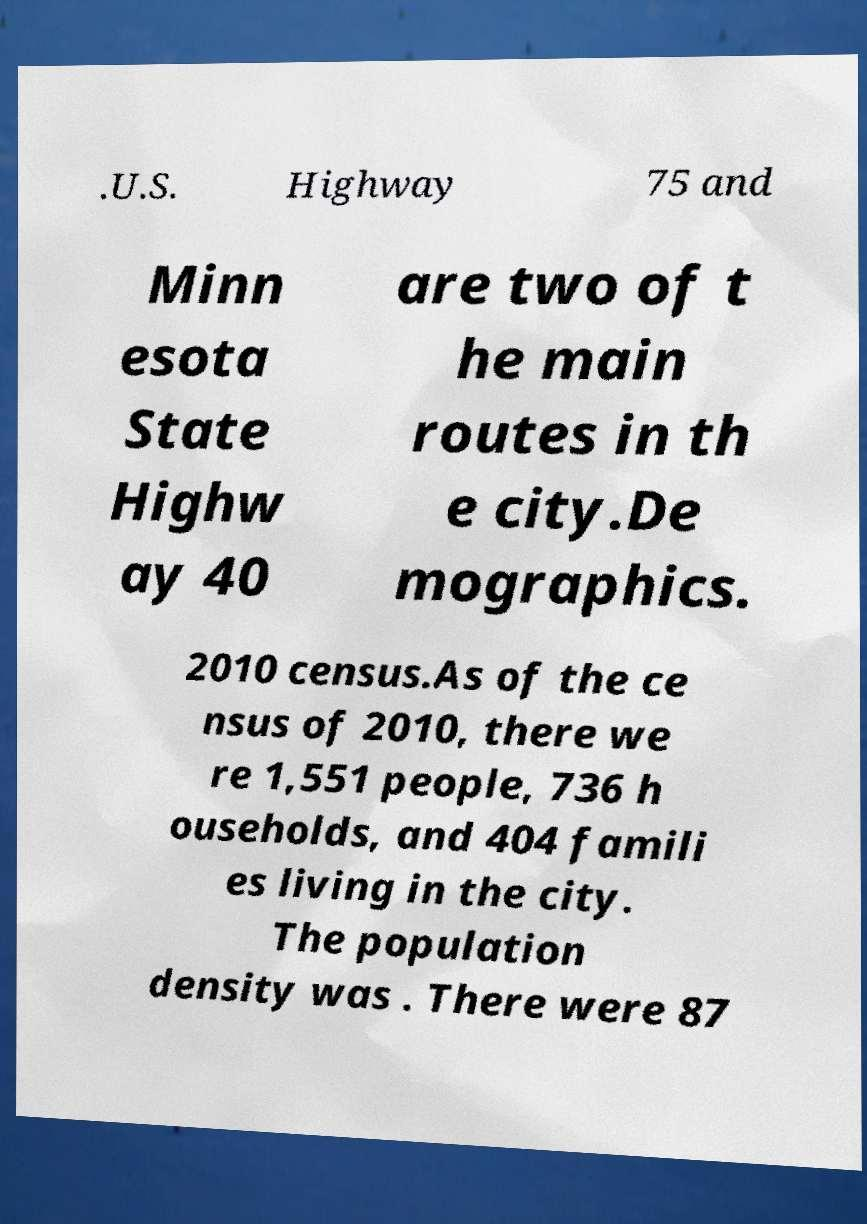Please identify and transcribe the text found in this image. .U.S. Highway 75 and Minn esota State Highw ay 40 are two of t he main routes in th e city.De mographics. 2010 census.As of the ce nsus of 2010, there we re 1,551 people, 736 h ouseholds, and 404 famili es living in the city. The population density was . There were 87 